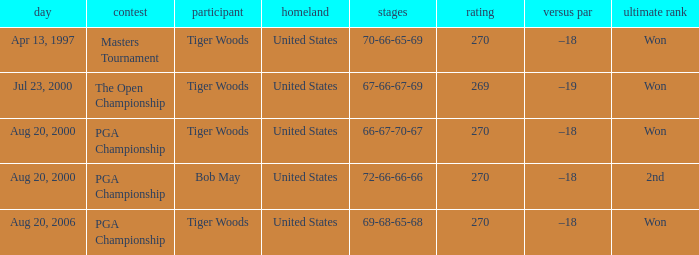What is the worst (highest) score? 270.0. Write the full table. {'header': ['day', 'contest', 'participant', 'homeland', 'stages', 'rating', 'versus par', 'ultimate rank'], 'rows': [['Apr 13, 1997', 'Masters Tournament', 'Tiger Woods', 'United States', '70-66-65-69', '270', '–18', 'Won'], ['Jul 23, 2000', 'The Open Championship', 'Tiger Woods', 'United States', '67-66-67-69', '269', '–19', 'Won'], ['Aug 20, 2000', 'PGA Championship', 'Tiger Woods', 'United States', '66-67-70-67', '270', '–18', 'Won'], ['Aug 20, 2000', 'PGA Championship', 'Bob May', 'United States', '72-66-66-66', '270', '–18', '2nd'], ['Aug 20, 2006', 'PGA Championship', 'Tiger Woods', 'United States', '69-68-65-68', '270', '–18', 'Won']]} 